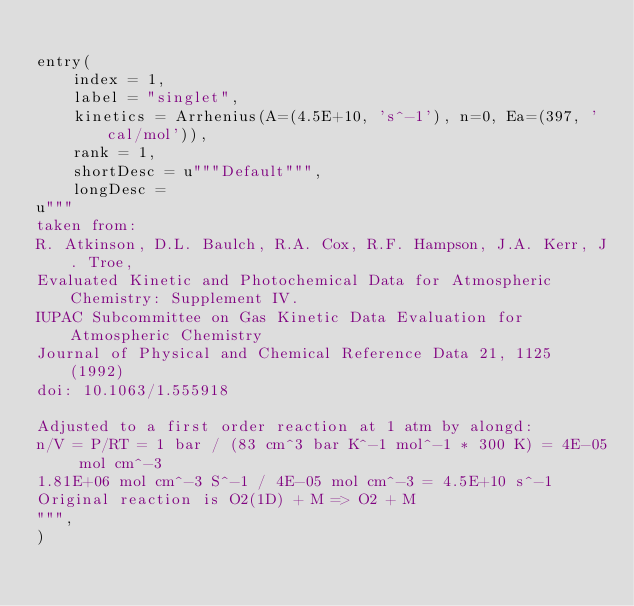<code> <loc_0><loc_0><loc_500><loc_500><_Python_>
entry(
    index = 1,
    label = "singlet",
    kinetics = Arrhenius(A=(4.5E+10, 's^-1'), n=0, Ea=(397, 'cal/mol')),
    rank = 1,
    shortDesc = u"""Default""",
    longDesc =
u"""
taken from:
R. Atkinson, D.L. Baulch, R.A. Cox, R.F. Hampson, J.A. Kerr, J. Troe,
Evaluated Kinetic and Photochemical Data for Atmospheric Chemistry: Supplement IV.
IUPAC Subcommittee on Gas Kinetic Data Evaluation for Atmospheric Chemistry
Journal of Physical and Chemical Reference Data 21, 1125 (1992)
doi: 10.1063/1.555918

Adjusted to a first order reaction at 1 atm by alongd:
n/V = P/RT = 1 bar / (83 cm^3 bar K^-1 mol^-1 * 300 K) = 4E-05 mol cm^-3
1.81E+06 mol cm^-3 S^-1 / 4E-05 mol cm^-3 = 4.5E+10 s^-1
Original reaction is O2(1D) + M => O2 + M
""",
)
</code> 